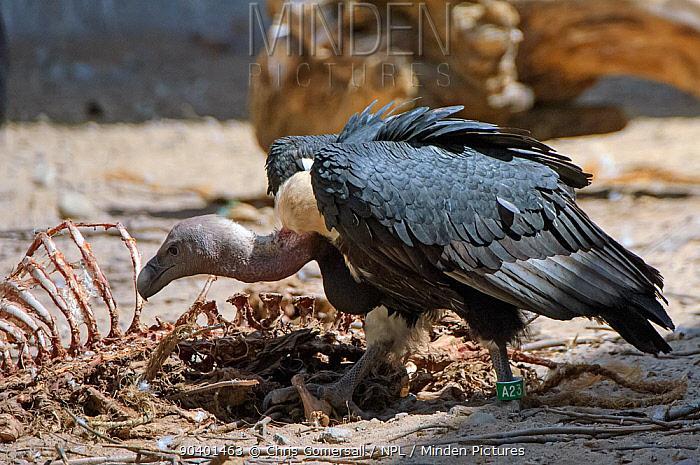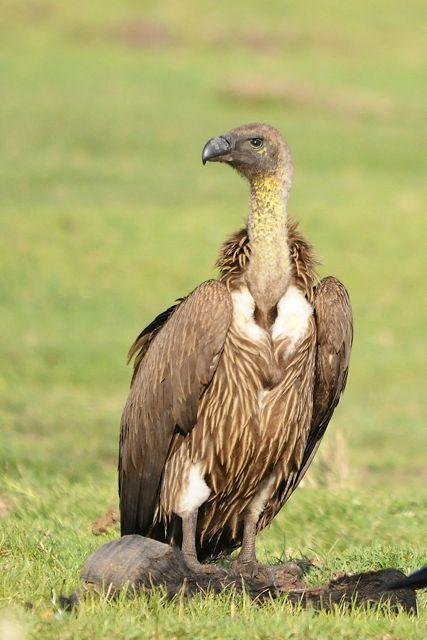The first image is the image on the left, the second image is the image on the right. Analyze the images presented: Is the assertion "birds are feeding off a carcass" valid? Answer yes or no. Yes. The first image is the image on the left, the second image is the image on the right. For the images displayed, is the sentence "There is no more than three birds." factually correct? Answer yes or no. Yes. 